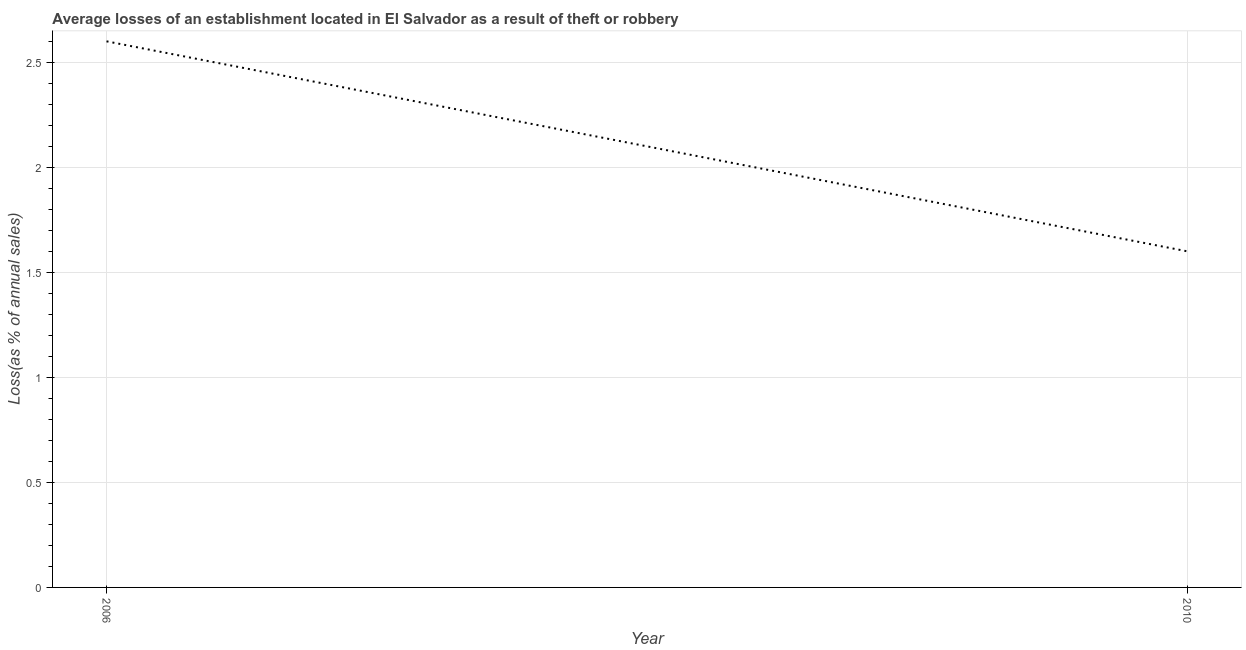Across all years, what is the minimum losses due to theft?
Offer a terse response. 1.6. In which year was the losses due to theft minimum?
Your answer should be compact. 2010. What is the sum of the losses due to theft?
Your answer should be very brief. 4.2. What is the difference between the losses due to theft in 2006 and 2010?
Ensure brevity in your answer.  1. What is the average losses due to theft per year?
Keep it short and to the point. 2.1. What is the median losses due to theft?
Provide a short and direct response. 2.1. In how many years, is the losses due to theft greater than 0.2 %?
Your response must be concise. 2. Do a majority of the years between 2010 and 2006 (inclusive) have losses due to theft greater than 1.1 %?
Your answer should be compact. No. What is the ratio of the losses due to theft in 2006 to that in 2010?
Provide a succinct answer. 1.62. Does the losses due to theft monotonically increase over the years?
Your answer should be very brief. No. How many lines are there?
Offer a very short reply. 1. How many years are there in the graph?
Give a very brief answer. 2. Does the graph contain any zero values?
Keep it short and to the point. No. Does the graph contain grids?
Offer a terse response. Yes. What is the title of the graph?
Offer a very short reply. Average losses of an establishment located in El Salvador as a result of theft or robbery. What is the label or title of the X-axis?
Provide a short and direct response. Year. What is the label or title of the Y-axis?
Keep it short and to the point. Loss(as % of annual sales). What is the difference between the Loss(as % of annual sales) in 2006 and 2010?
Your response must be concise. 1. What is the ratio of the Loss(as % of annual sales) in 2006 to that in 2010?
Provide a succinct answer. 1.62. 